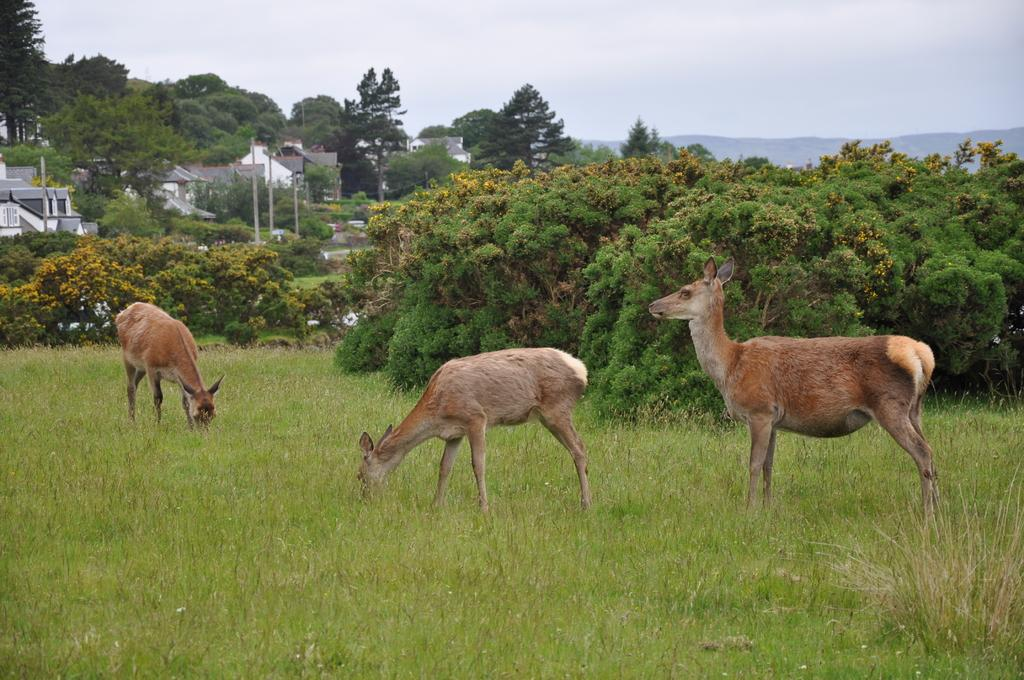What types of living organisms can be seen in the image? There are animals in the image. What type of vegetation is at the bottom of the image? There is grass at the bottom of the image. What can be seen in the background of the image? Trees, buildings, poles, and hills are visible in the background of the image. What part of the natural environment is visible in the image? The natural environment includes grass, trees, hills, and the sky. What type of hat is the animal wearing in the image? There are no animals wearing hats in the image. What sounds can be heard coming from the market in the image? There is no market present in the image, so it's not possible to determine what sounds might be heard. 